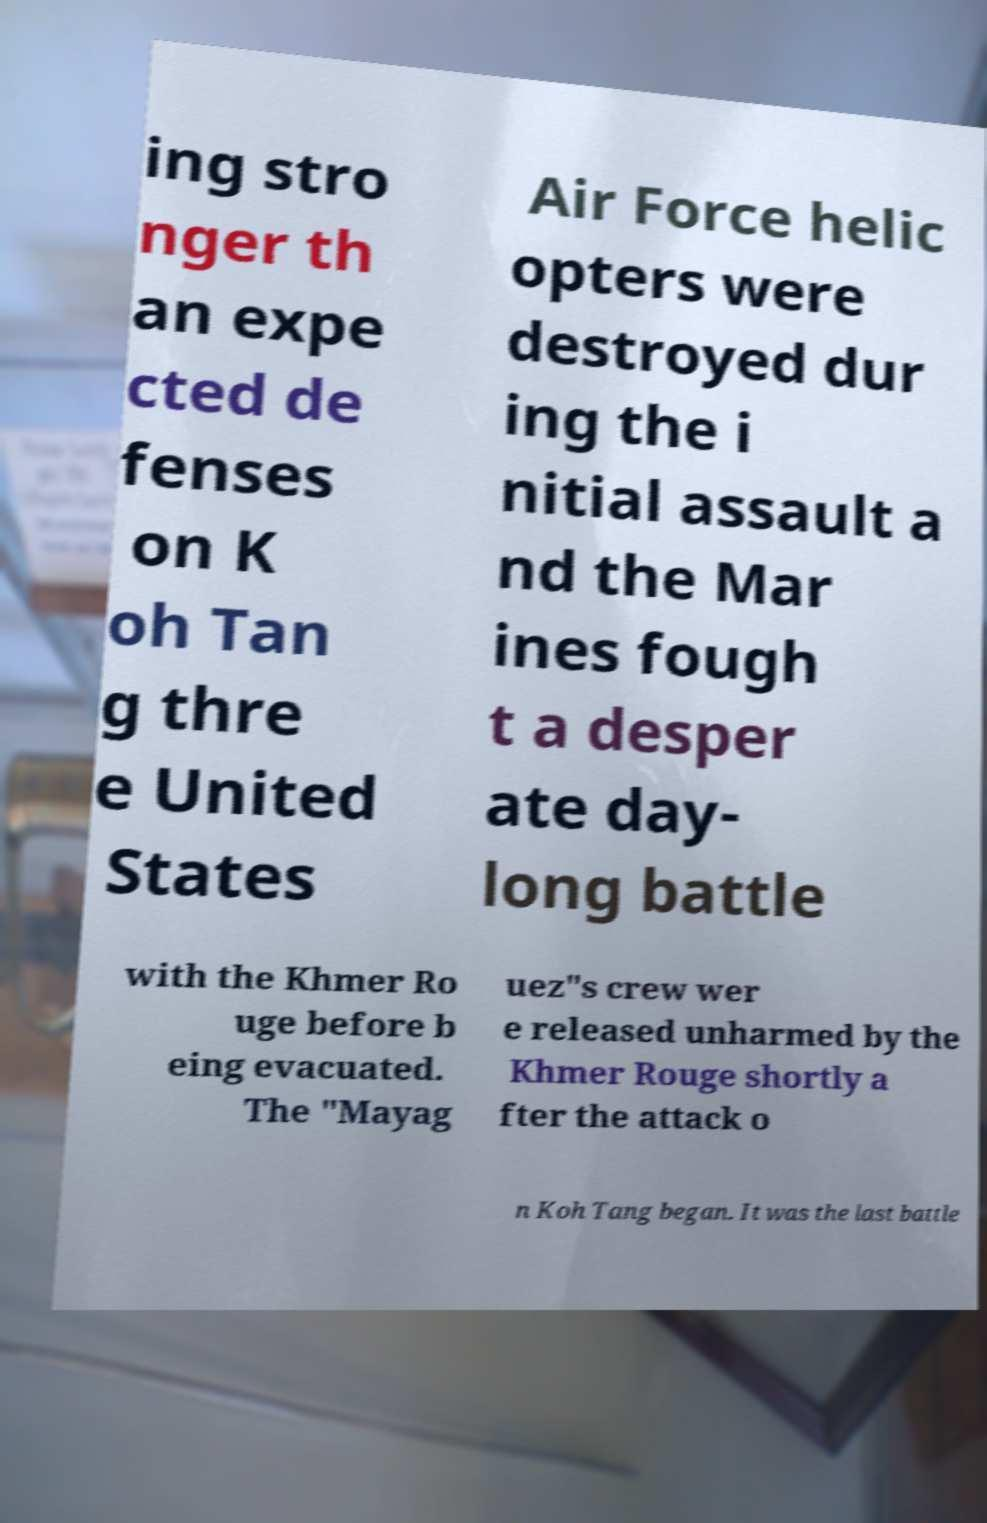Please read and relay the text visible in this image. What does it say? ing stro nger th an expe cted de fenses on K oh Tan g thre e United States Air Force helic opters were destroyed dur ing the i nitial assault a nd the Mar ines fough t a desper ate day- long battle with the Khmer Ro uge before b eing evacuated. The "Mayag uez"s crew wer e released unharmed by the Khmer Rouge shortly a fter the attack o n Koh Tang began. It was the last battle 